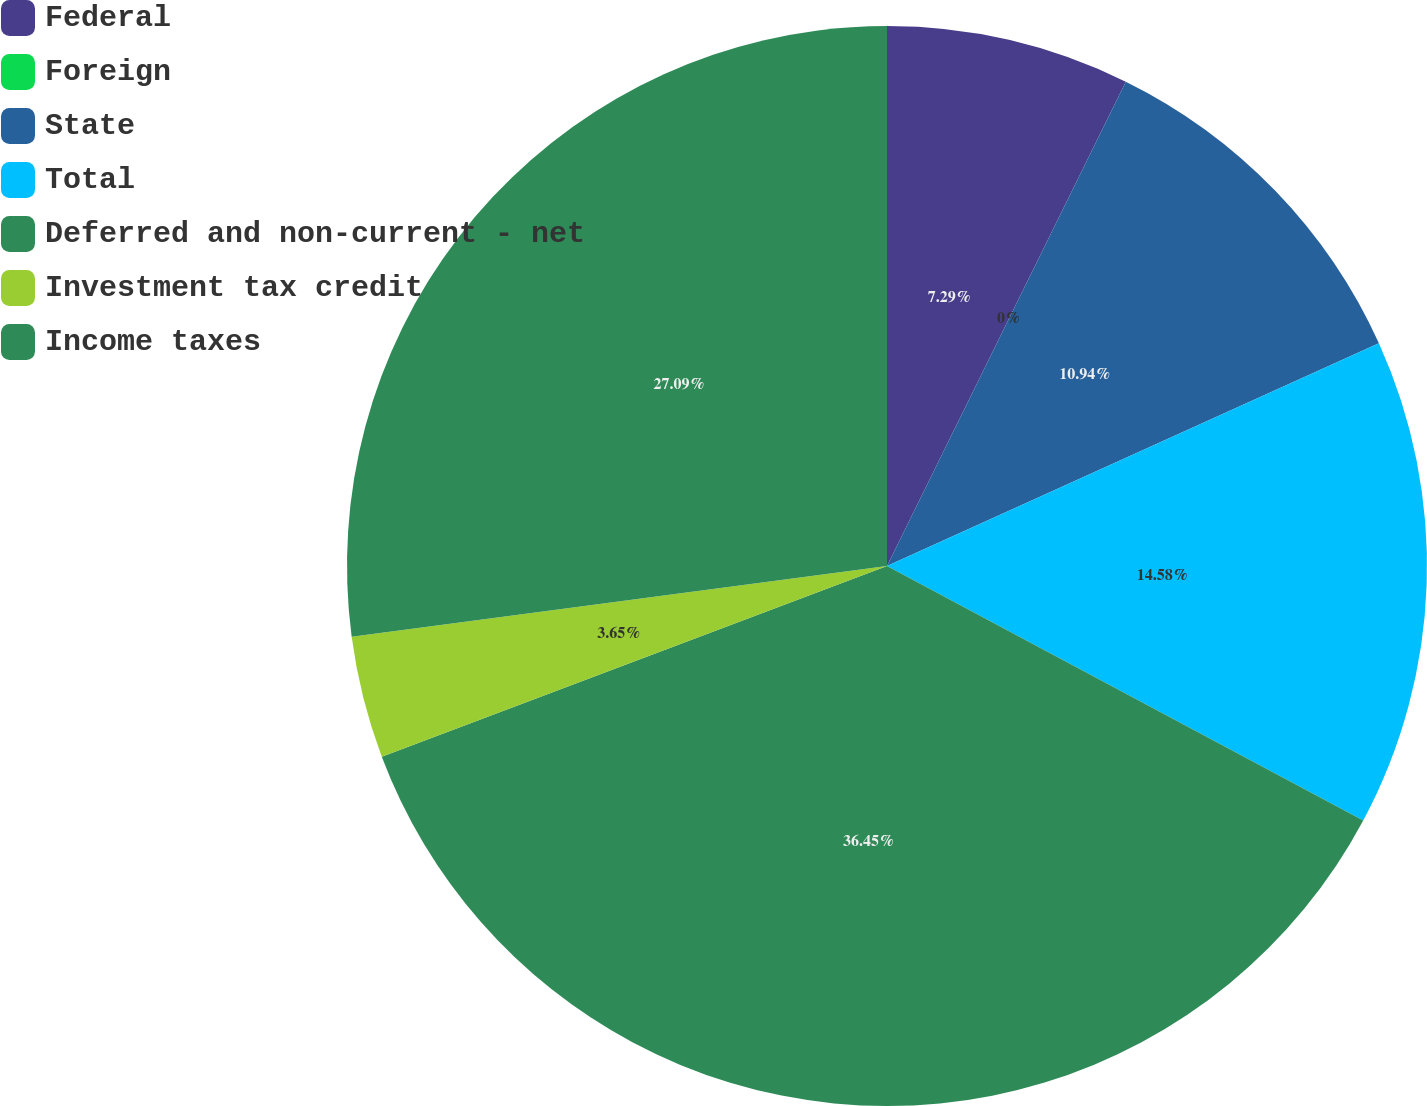Convert chart. <chart><loc_0><loc_0><loc_500><loc_500><pie_chart><fcel>Federal<fcel>Foreign<fcel>State<fcel>Total<fcel>Deferred and non-current - net<fcel>Investment tax credit<fcel>Income taxes<nl><fcel>7.29%<fcel>0.0%<fcel>10.94%<fcel>14.58%<fcel>36.44%<fcel>3.65%<fcel>27.09%<nl></chart> 